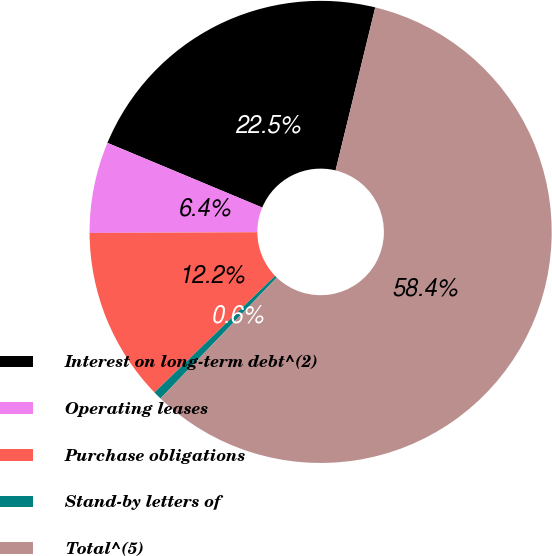Convert chart. <chart><loc_0><loc_0><loc_500><loc_500><pie_chart><fcel>Interest on long-term debt^(2)<fcel>Operating leases<fcel>Purchase obligations<fcel>Stand-by letters of<fcel>Total^(5)<nl><fcel>22.5%<fcel>6.37%<fcel>12.15%<fcel>0.59%<fcel>58.38%<nl></chart> 